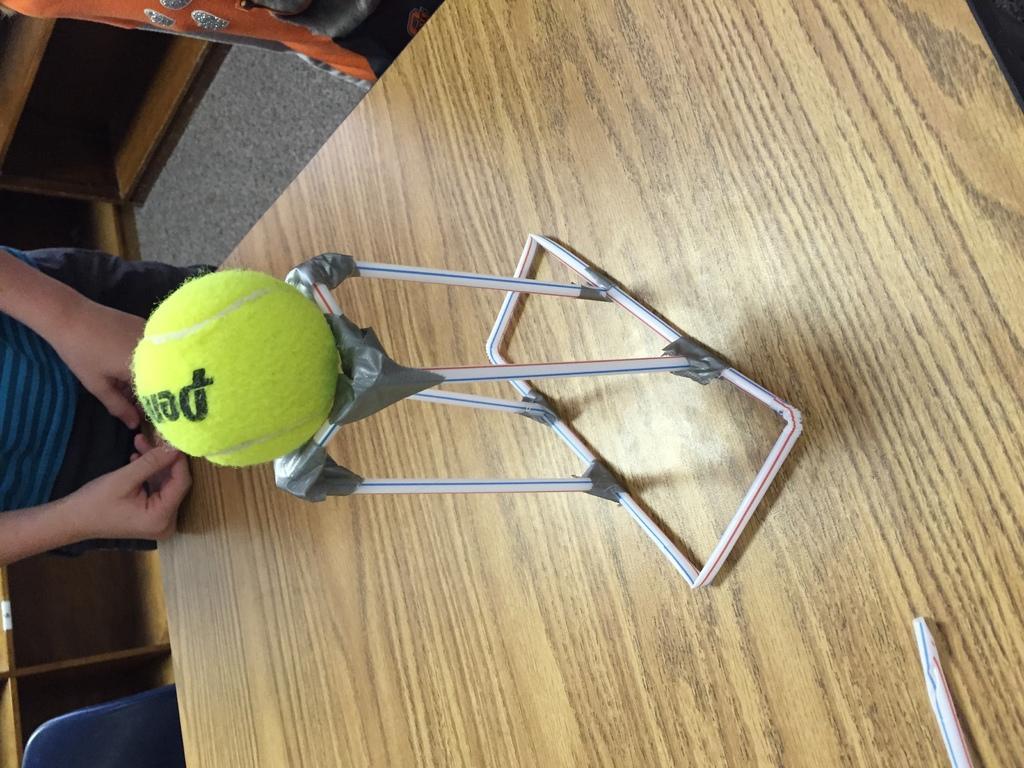How would you summarize this image in a sentence or two? Above the table there is are straws and tennis ball. At the left side of the image we can see cupboards, floor with carpet, chair and a person.  